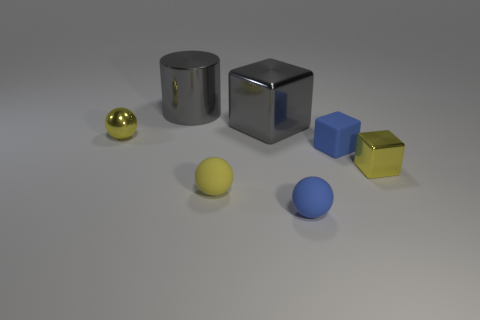Add 3 blocks. How many objects exist? 10 Subtract all spheres. How many objects are left? 4 Subtract 0 brown balls. How many objects are left? 7 Subtract all large purple metallic spheres. Subtract all gray metal cubes. How many objects are left? 6 Add 4 blue balls. How many blue balls are left? 5 Add 7 small blue matte cylinders. How many small blue matte cylinders exist? 7 